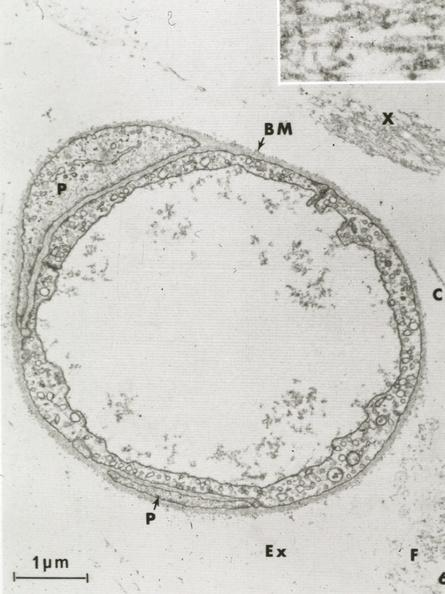s vasculature present?
Answer the question using a single word or phrase. Yes 